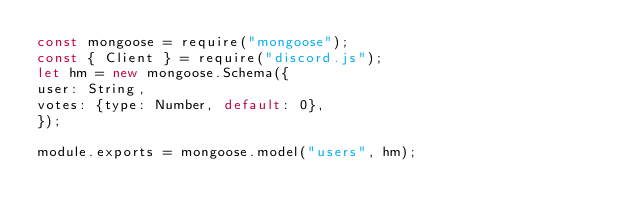<code> <loc_0><loc_0><loc_500><loc_500><_JavaScript_>const mongoose = require("mongoose");
const { Client } = require("discord.js");
let hm = new mongoose.Schema({
user: String,
votes: {type: Number, default: 0},
});

module.exports = mongoose.model("users", hm);</code> 